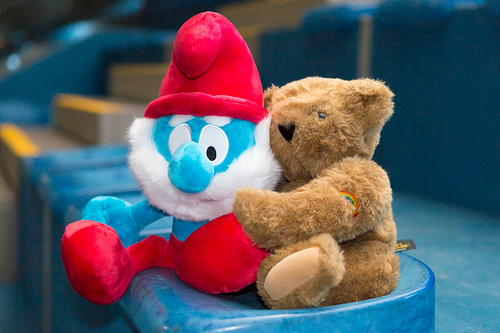<image>
Can you confirm if the smurf is next to the teddy? Yes. The smurf is positioned adjacent to the teddy, located nearby in the same general area. Is the smurf in front of the stairs? Yes. The smurf is positioned in front of the stairs, appearing closer to the camera viewpoint. 